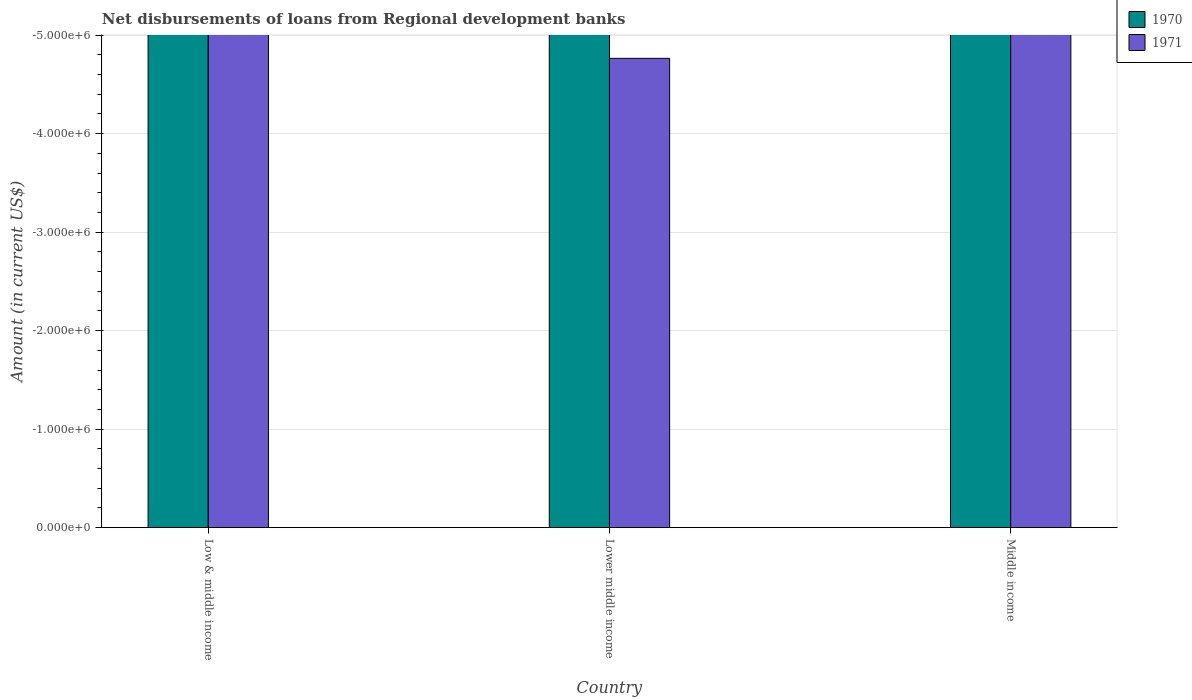How many different coloured bars are there?
Give a very brief answer. 0. Are the number of bars per tick equal to the number of legend labels?
Provide a short and direct response. No. How many bars are there on the 1st tick from the right?
Ensure brevity in your answer.  0. In how many cases, is the number of bars for a given country not equal to the number of legend labels?
Your response must be concise. 3. What is the amount of disbursements of loans from regional development banks in 1971 in Middle income?
Ensure brevity in your answer.  0. What is the difference between the amount of disbursements of loans from regional development banks in 1970 in Lower middle income and the amount of disbursements of loans from regional development banks in 1971 in Low & middle income?
Give a very brief answer. 0. In how many countries, is the amount of disbursements of loans from regional development banks in 1970 greater than -3000000 US$?
Ensure brevity in your answer.  0. Are all the bars in the graph horizontal?
Give a very brief answer. No. How many countries are there in the graph?
Keep it short and to the point. 3. Are the values on the major ticks of Y-axis written in scientific E-notation?
Your response must be concise. Yes. Does the graph contain any zero values?
Ensure brevity in your answer.  Yes. Does the graph contain grids?
Provide a succinct answer. Yes. How many legend labels are there?
Provide a succinct answer. 2. How are the legend labels stacked?
Give a very brief answer. Vertical. What is the title of the graph?
Your answer should be very brief. Net disbursements of loans from Regional development banks. What is the Amount (in current US$) of 1970 in Low & middle income?
Your answer should be compact. 0. What is the Amount (in current US$) in 1970 in Lower middle income?
Provide a succinct answer. 0. What is the Amount (in current US$) of 1971 in Lower middle income?
Make the answer very short. 0. What is the Amount (in current US$) in 1970 in Middle income?
Offer a very short reply. 0. What is the average Amount (in current US$) of 1971 per country?
Your response must be concise. 0. 